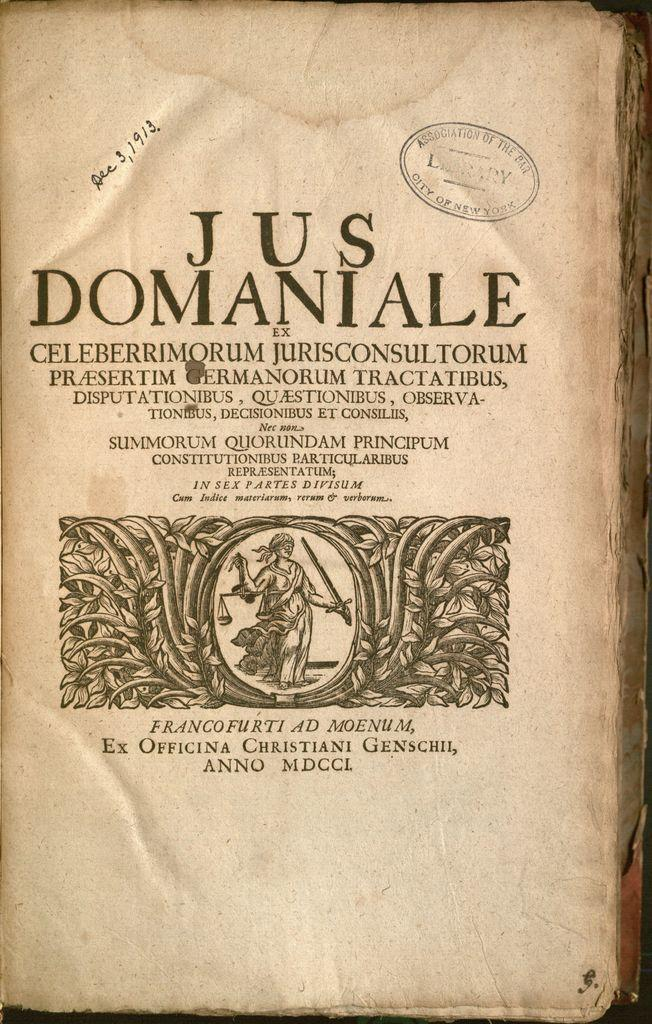<image>
Write a terse but informative summary of the picture. The hand written date December 3,1913 is on the title page of a book. 